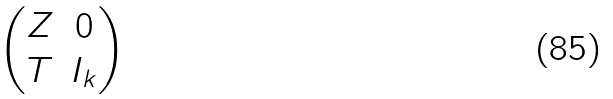<formula> <loc_0><loc_0><loc_500><loc_500>\begin{pmatrix} Z & 0 \\ T & I _ { k } \end{pmatrix}</formula> 